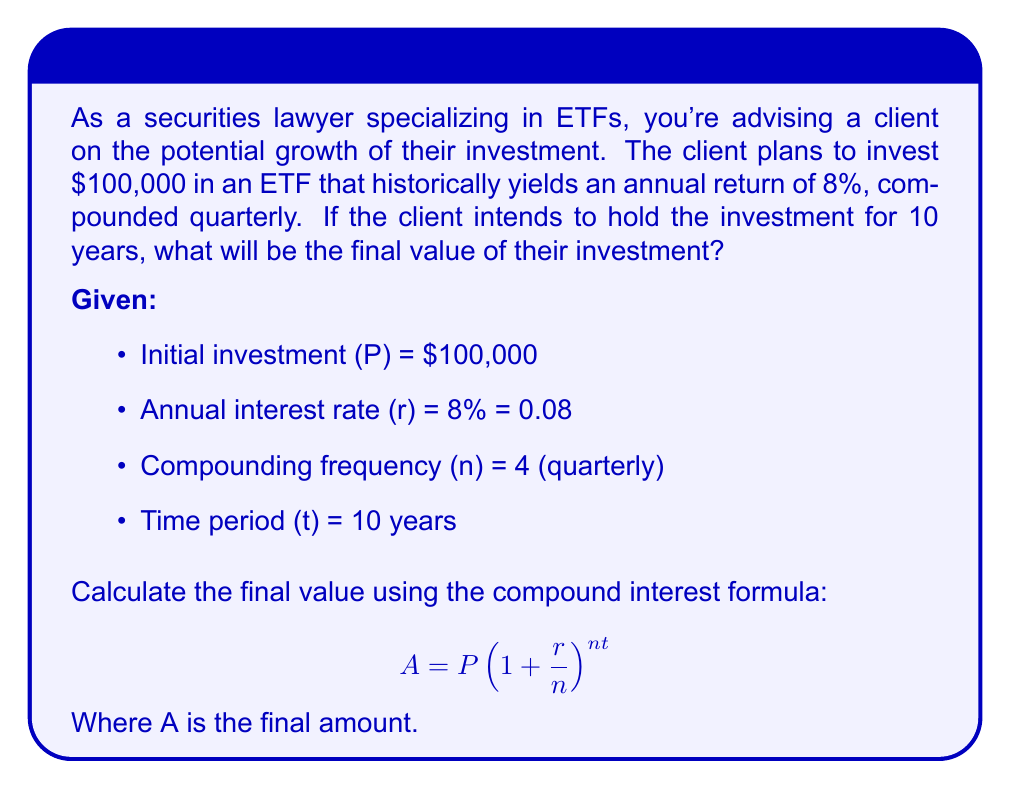Give your solution to this math problem. Let's solve this step-by-step:

1) We have the compound interest formula:
   $$A = P(1 + \frac{r}{n})^{nt}$$

2) Substituting the given values:
   $$A = 100000(1 + \frac{0.08}{4})^{4 \cdot 10}$$

3) Simplify the fraction inside the parentheses:
   $$A = 100000(1 + 0.02)^{40}$$

4) Calculate the value inside the parentheses:
   $$A = 100000(1.02)^{40}$$

5) Use a calculator or computer to evaluate $(1.02)^{40}$:
   $(1.02)^{40} \approx 2.2080399$

6) Multiply this by the initial investment:
   $$A = 100000 \cdot 2.2080399 = 220803.99$$

Therefore, the final value of the investment after 10 years will be approximately $220,803.99.
Answer: $220,803.99 